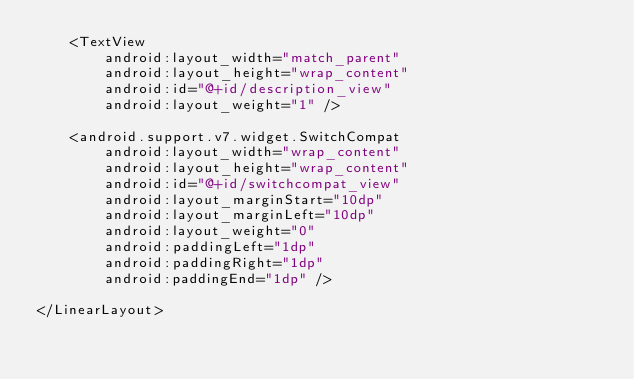Convert code to text. <code><loc_0><loc_0><loc_500><loc_500><_XML_>    <TextView
        android:layout_width="match_parent"
        android:layout_height="wrap_content"
        android:id="@+id/description_view"
        android:layout_weight="1" />

    <android.support.v7.widget.SwitchCompat
        android:layout_width="wrap_content"
        android:layout_height="wrap_content"
        android:id="@+id/switchcompat_view"
        android:layout_marginStart="10dp"
        android:layout_marginLeft="10dp"
        android:layout_weight="0"
        android:paddingLeft="1dp"
        android:paddingRight="1dp"
        android:paddingEnd="1dp" />

</LinearLayout></code> 